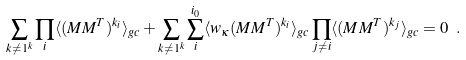Convert formula to latex. <formula><loc_0><loc_0><loc_500><loc_500>\sum _ { { k } \neq { 1 } ^ { k } } \prod _ { i } \langle ( M M ^ { T } ) ^ { k _ { i } } \rangle _ { g c } + \sum _ { { k } \neq { 1 } ^ { k } } \sum _ { i } ^ { i _ { 0 } } \langle w _ { \kappa } ( M M ^ { T } ) ^ { k _ { i } } \rangle _ { g c } \prod _ { j \neq i } \langle ( M M ^ { T } ) ^ { k _ { j } } \rangle _ { g c } = 0 \ .</formula> 